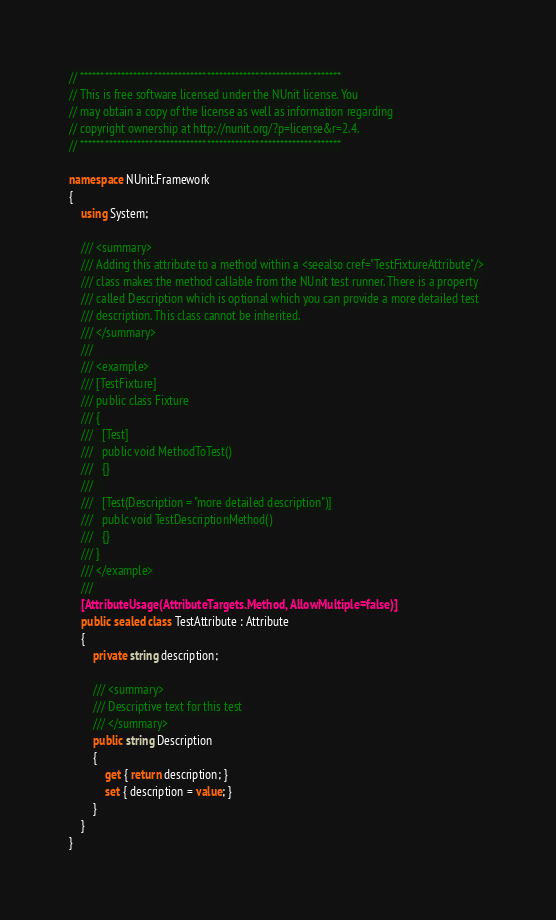Convert code to text. <code><loc_0><loc_0><loc_500><loc_500><_C#_>// ****************************************************************
// This is free software licensed under the NUnit license. You
// may obtain a copy of the license as well as information regarding
// copyright ownership at http://nunit.org/?p=license&r=2.4.
// ****************************************************************

namespace NUnit.Framework
{
	using System;

	/// <summary>
	/// Adding this attribute to a method within a <seealso cref="TestFixtureAttribute"/> 
	/// class makes the method callable from the NUnit test runner. There is a property 
	/// called Description which is optional which you can provide a more detailed test
	/// description. This class cannot be inherited.
	/// </summary>
	/// 
	/// <example>
	/// [TestFixture]
	/// public class Fixture
	/// {
	///   [Test]
	///   public void MethodToTest()
	///   {}
	///   
	///   [Test(Description = "more detailed description")]
	///   publc void TestDescriptionMethod()
	///   {}
	/// }
	/// </example>
	/// 
	[AttributeUsage(AttributeTargets.Method, AllowMultiple=false)]
	public sealed class TestAttribute : Attribute
	{
		private string description;

		/// <summary>
		/// Descriptive text for this test
		/// </summary>
		public string Description
		{
			get { return description; }
			set { description = value; }
		}
	}
}
</code> 